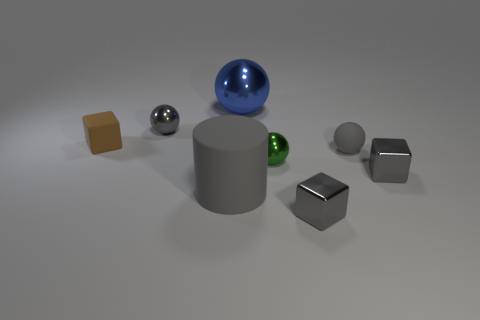What might be the purpose of this arrangement of objects? This arrangement of objects seems to be a deliberate setup for demonstrating materials and lighting in 3D modeling. Each object reflects or absorbs light differently, which could be used to showcase how various textures and surfaces react to a set light source in a controlled environment. Does anything indicate which light source is being used here? The shadows cast by the objects and the highlights on the glossy surfaces suggest there is at least one primary light source positioned above and slightly to the front of the scene. There's a soft diffused light, which creates soft-edged shadows, hinting that the environment might be utilizing global illumination techniques often used in 3D rendering. 